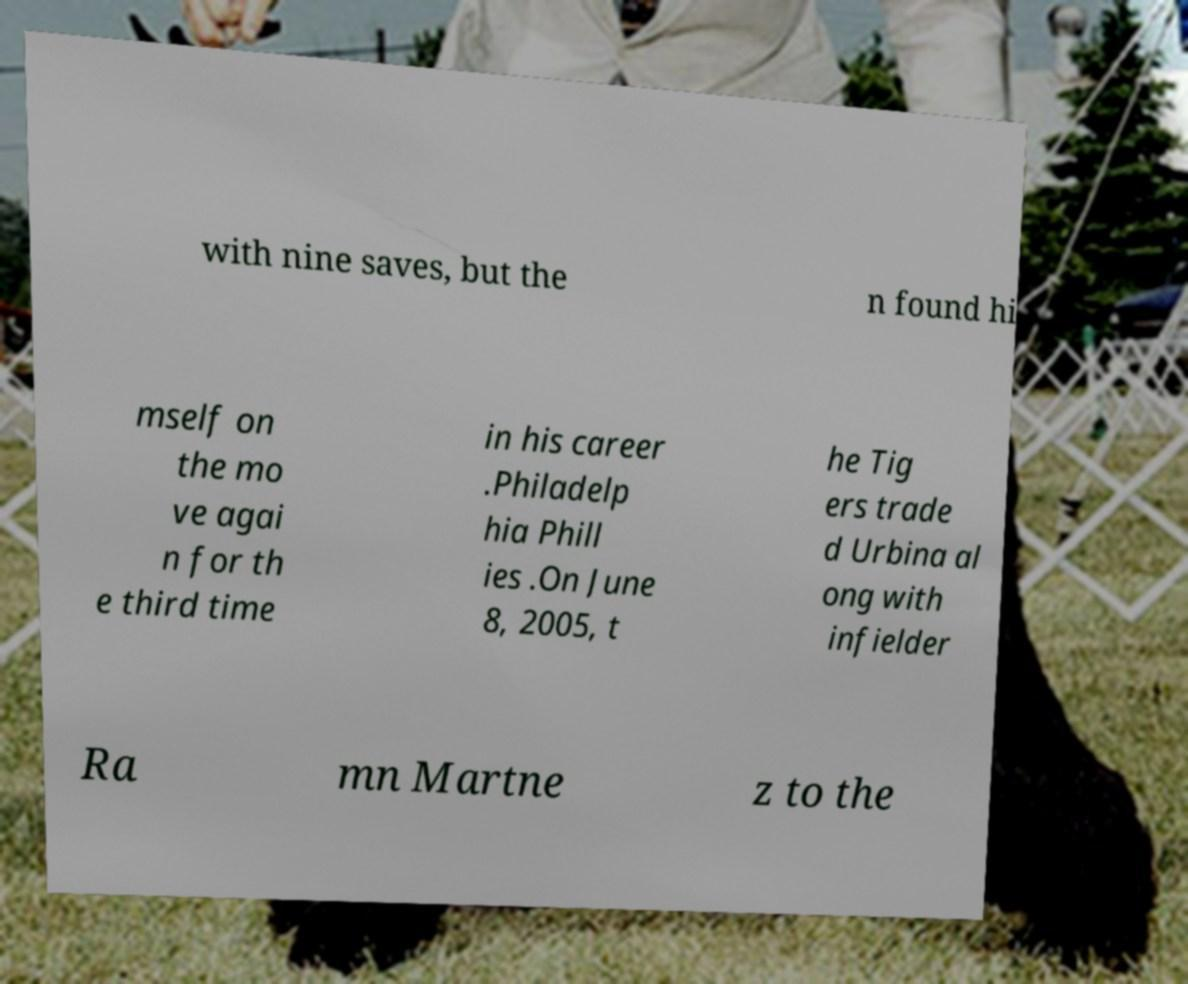For documentation purposes, I need the text within this image transcribed. Could you provide that? with nine saves, but the n found hi mself on the mo ve agai n for th e third time in his career .Philadelp hia Phill ies .On June 8, 2005, t he Tig ers trade d Urbina al ong with infielder Ra mn Martne z to the 